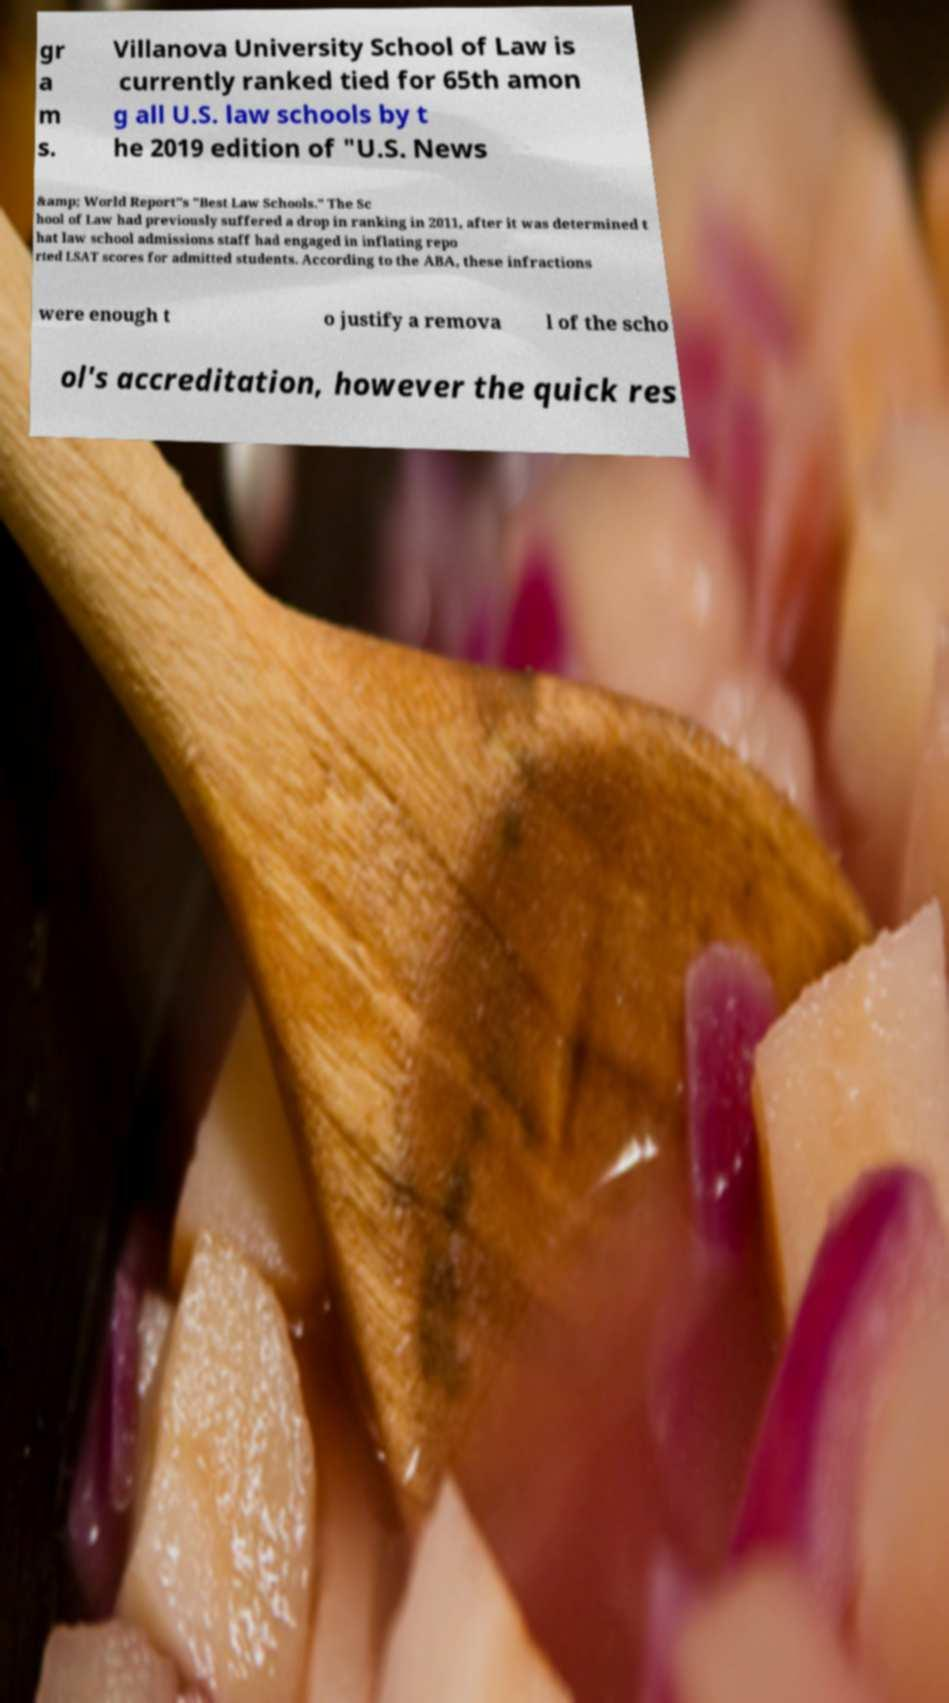Can you read and provide the text displayed in the image?This photo seems to have some interesting text. Can you extract and type it out for me? gr a m s. Villanova University School of Law is currently ranked tied for 65th amon g all U.S. law schools by t he 2019 edition of "U.S. News &amp; World Report"s "Best Law Schools." The Sc hool of Law had previously suffered a drop in ranking in 2011, after it was determined t hat law school admissions staff had engaged in inflating repo rted LSAT scores for admitted students. According to the ABA, these infractions were enough t o justify a remova l of the scho ol's accreditation, however the quick res 